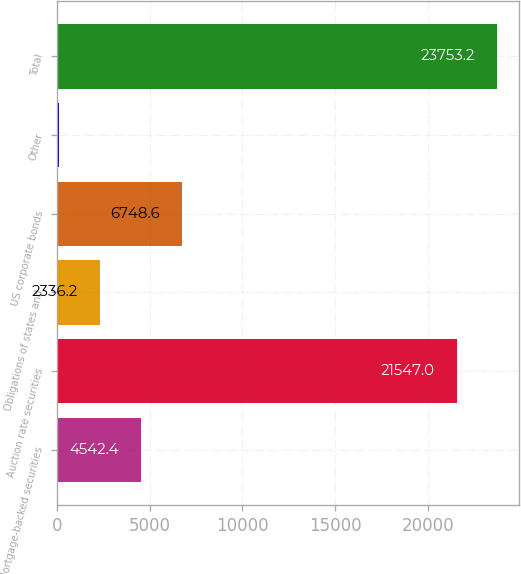Convert chart to OTSL. <chart><loc_0><loc_0><loc_500><loc_500><bar_chart><fcel>Mortgage-backed securities<fcel>Auction rate securities<fcel>Obligations of states and<fcel>US corporate bonds<fcel>Other<fcel>Total<nl><fcel>4542.4<fcel>21547<fcel>2336.2<fcel>6748.6<fcel>130<fcel>23753.2<nl></chart> 